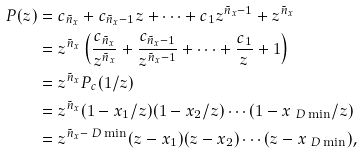<formula> <loc_0><loc_0><loc_500><loc_500>P ( z ) & = c _ { \tilde { n } _ { x } } + c _ { \tilde { n } _ { x } - 1 } z + \cdots + c _ { 1 } z ^ { \tilde { n } _ { x } - 1 } + z ^ { \tilde { n } _ { x } } \\ & = z ^ { \tilde { n } _ { x } } \left ( \frac { c _ { \tilde { n } _ { x } } } { z ^ { \tilde { n } _ { x } } } + \frac { c _ { \tilde { n } _ { x } - 1 } } { z ^ { \tilde { n } _ { x } - 1 } } + \cdots + \frac { c _ { 1 } } { z } + 1 \right ) \\ & = z ^ { \tilde { n } _ { x } } P _ { c } ( 1 / z ) \\ & = z ^ { \tilde { n } _ { x } } ( 1 - x _ { 1 } / z ) ( 1 - x _ { 2 } / z ) \cdots ( 1 - x _ { \ D \min } / z ) \\ & = z ^ { \tilde { n } _ { x } - \ D \min } ( z - x _ { 1 } ) ( z - x _ { 2 } ) \cdots ( z - x _ { \ D \min } ) ,</formula> 